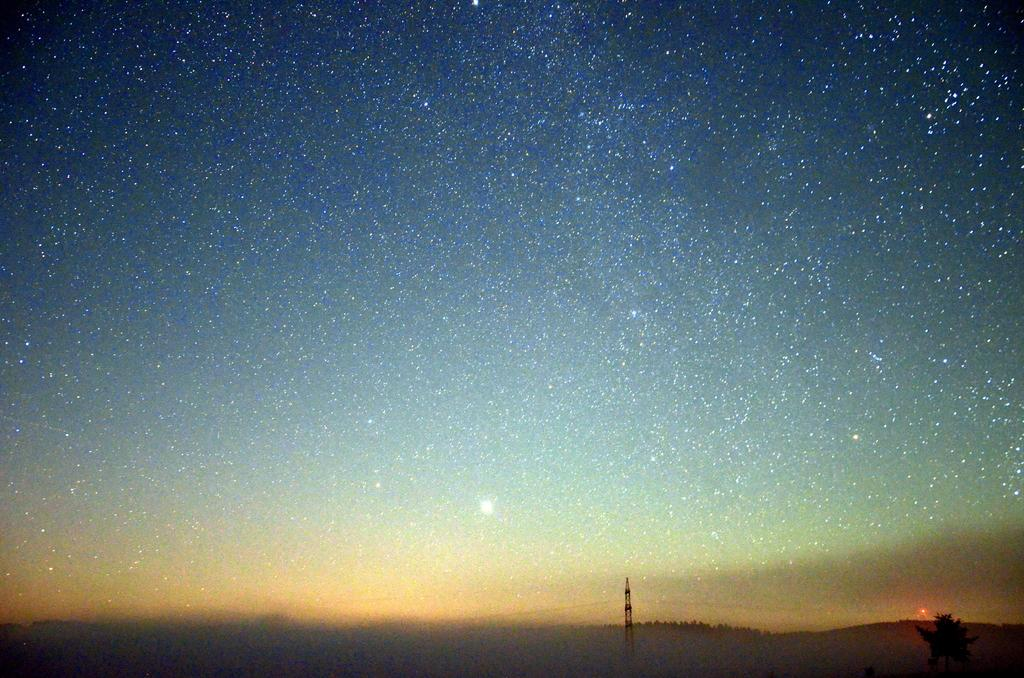What celestial objects can be seen in the sky in the image? Stars are visible in the sky in the image. What structure is located at the bottom of the picture? There is a transmission tower at the bottom of the picture. What type of plant is present in the image? There is a tree in the image. What type of floor can be seen in the image? There is no floor visible in the image; it features stars in the sky, a transmission tower, and a tree. How many cows are present in the image? There are no cows present in the image. 